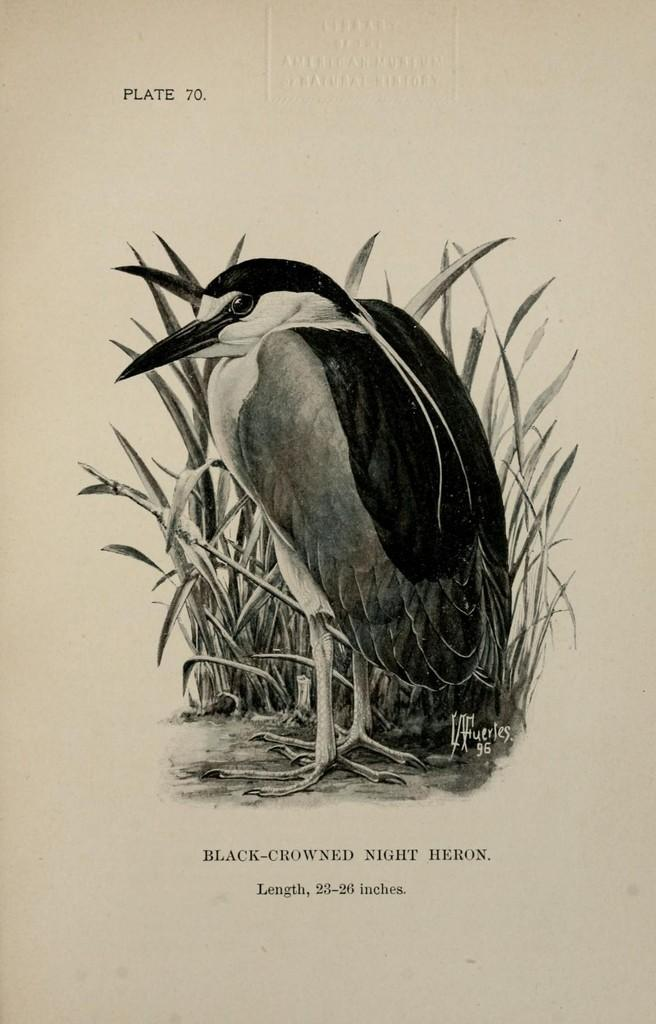What type of image is being described? The image is animated. What can be seen in the foreground of the image? There is a bird in the foreground of the image. What is visible in the background of the image? There are plants in the background of the image. What type of humor can be seen in the image? There is no humor present in the image; it is an animated scene featuring a bird and plants. 